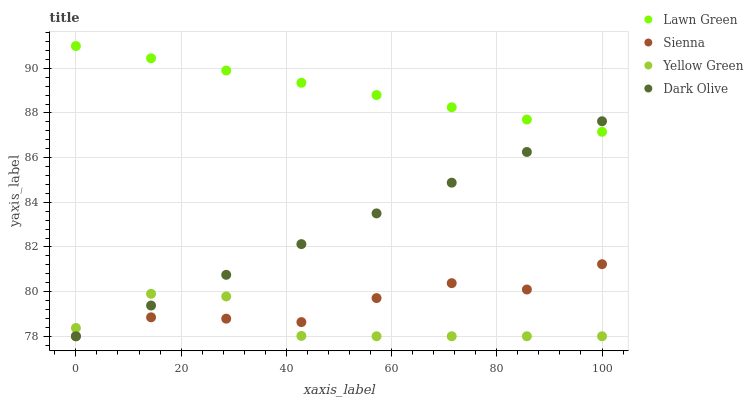Does Yellow Green have the minimum area under the curve?
Answer yes or no. Yes. Does Lawn Green have the maximum area under the curve?
Answer yes or no. Yes. Does Dark Olive have the minimum area under the curve?
Answer yes or no. No. Does Dark Olive have the maximum area under the curve?
Answer yes or no. No. Is Dark Olive the smoothest?
Answer yes or no. Yes. Is Yellow Green the roughest?
Answer yes or no. Yes. Is Lawn Green the smoothest?
Answer yes or no. No. Is Lawn Green the roughest?
Answer yes or no. No. Does Sienna have the lowest value?
Answer yes or no. Yes. Does Lawn Green have the lowest value?
Answer yes or no. No. Does Lawn Green have the highest value?
Answer yes or no. Yes. Does Dark Olive have the highest value?
Answer yes or no. No. Is Sienna less than Lawn Green?
Answer yes or no. Yes. Is Lawn Green greater than Sienna?
Answer yes or no. Yes. Does Yellow Green intersect Dark Olive?
Answer yes or no. Yes. Is Yellow Green less than Dark Olive?
Answer yes or no. No. Is Yellow Green greater than Dark Olive?
Answer yes or no. No. Does Sienna intersect Lawn Green?
Answer yes or no. No. 